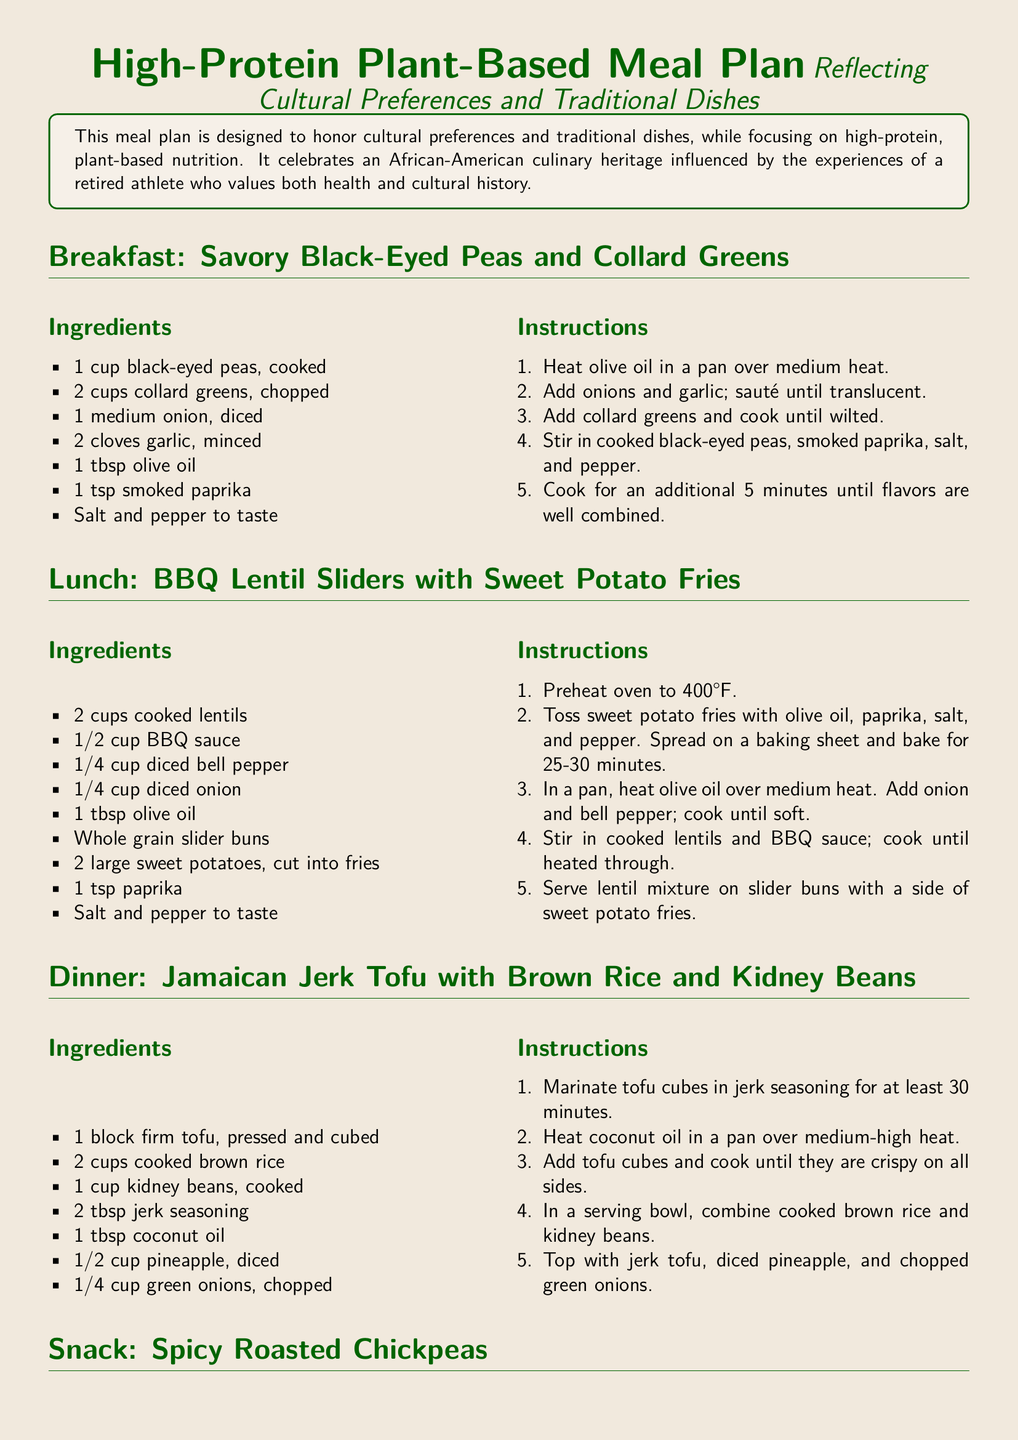What is the first meal listed in the document? The document begins with the breakfast section, which is Savory Black-Eyed Peas and Collard Greens.
Answer: Savory Black-Eyed Peas and Collard Greens How many cups of collard greens are needed for breakfast? The breakfast recipe lists 2 cups of collard greens as an ingredient.
Answer: 2 cups What dish is served for lunch? The lunch section of the document includes BBQ Lentil Sliders with Sweet Potato Fries.
Answer: BBQ Lentil Sliders with Sweet Potato Fries What ingredient is used to marinate the tofu for dinner? The dinner recipe specifies jerk seasoning as the marinade for the tofu.
Answer: Jerk seasoning How long should the chickpeas be roasted in the oven? The snack recipe states that chickpeas need to be roasted for 20-25 minutes until crispy.
Answer: 20-25 minutes What type of oil is used in the lunch recipe? The lunch recipe calls for olive oil in the preparation of the lentil sliders.
Answer: Olive oil Which traditional dish is highlighted in the meal plan? The meal plan reflects cultural preferences and includes traditional dishes like black-eyed peas and collard greens.
Answer: Black-eyed peas and collard greens What is the main protein source in the dinner recipe? The dinner section lists firm tofu as the main protein source.
Answer: Firm tofu What type of potato is used for fries in the lunch meal? The lunch recipe specifies using sweet potatoes for the fries.
Answer: Sweet potatoes 